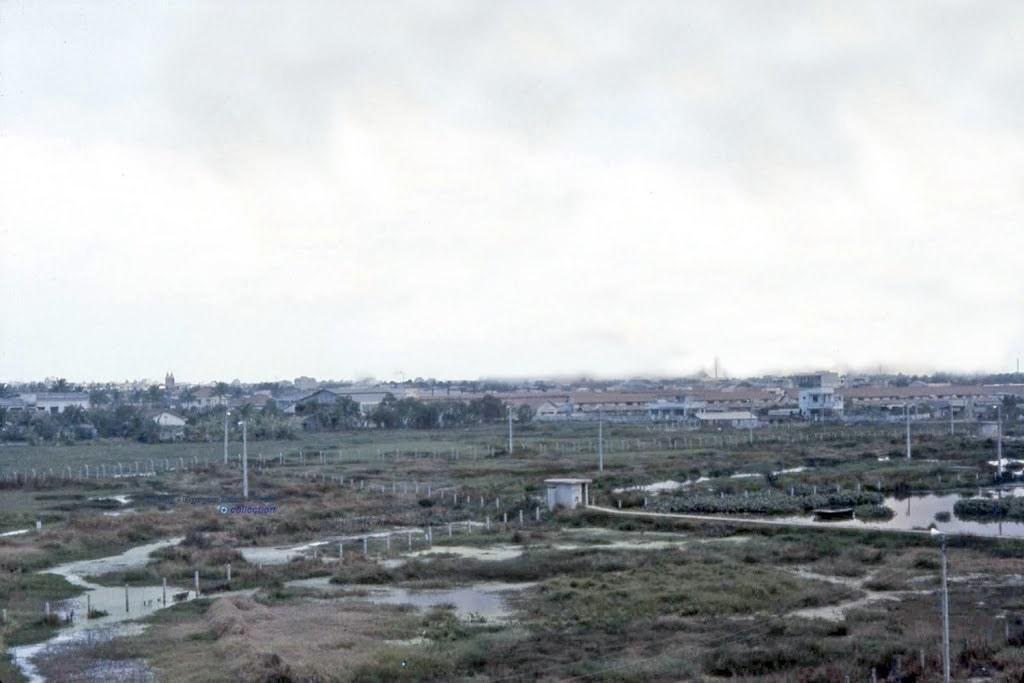What type of structures can be seen in the image? There are lamp posts, concrete poles, and houses visible in the image. What natural elements are present in the image? There is water, grass, bushes, and trees in the image. Can you describe the landscape in the image? The image features a mix of natural elements like water, grass, bushes, and trees, as well as man-made structures such as lamp posts, concrete poles, and houses. What type of cakes are being used to hold the concrete poles in place in the image? There are no cakes present in the image, and the concrete poles are not being held in place by any cakes. How is the glue being applied to the bushes in the image? There is no glue or application process visible in the image; it only features bushes as part of the landscape. 